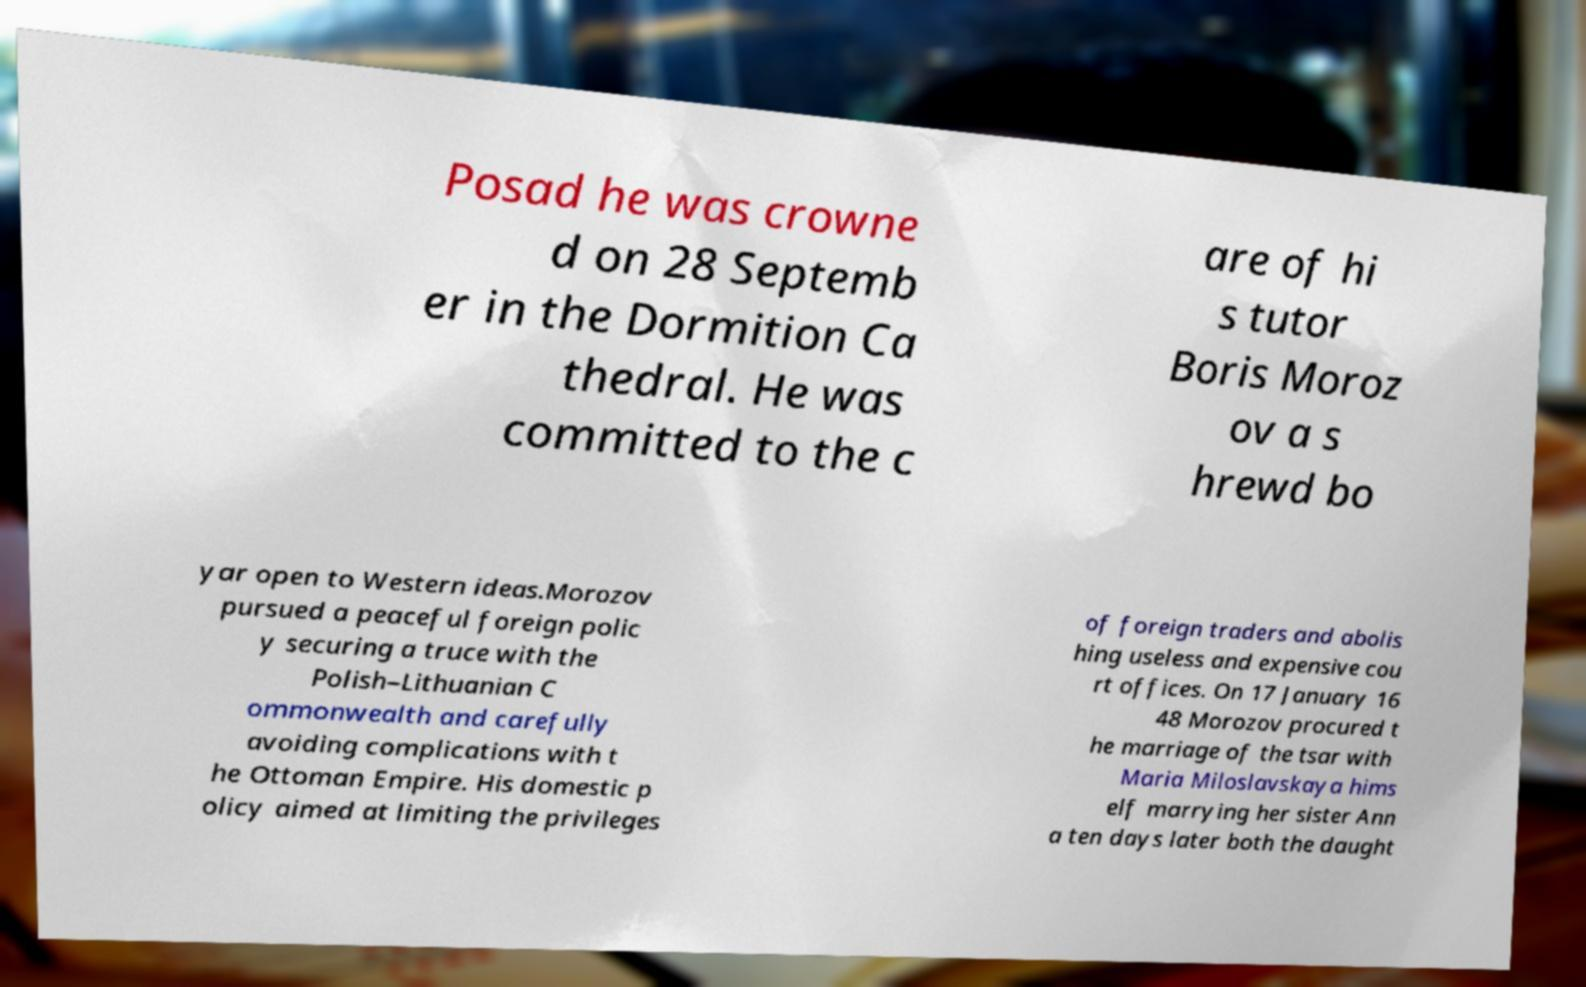Can you read and provide the text displayed in the image?This photo seems to have some interesting text. Can you extract and type it out for me? Posad he was crowne d on 28 Septemb er in the Dormition Ca thedral. He was committed to the c are of hi s tutor Boris Moroz ov a s hrewd bo yar open to Western ideas.Morozov pursued a peaceful foreign polic y securing a truce with the Polish–Lithuanian C ommonwealth and carefully avoiding complications with t he Ottoman Empire. His domestic p olicy aimed at limiting the privileges of foreign traders and abolis hing useless and expensive cou rt offices. On 17 January 16 48 Morozov procured t he marriage of the tsar with Maria Miloslavskaya hims elf marrying her sister Ann a ten days later both the daught 